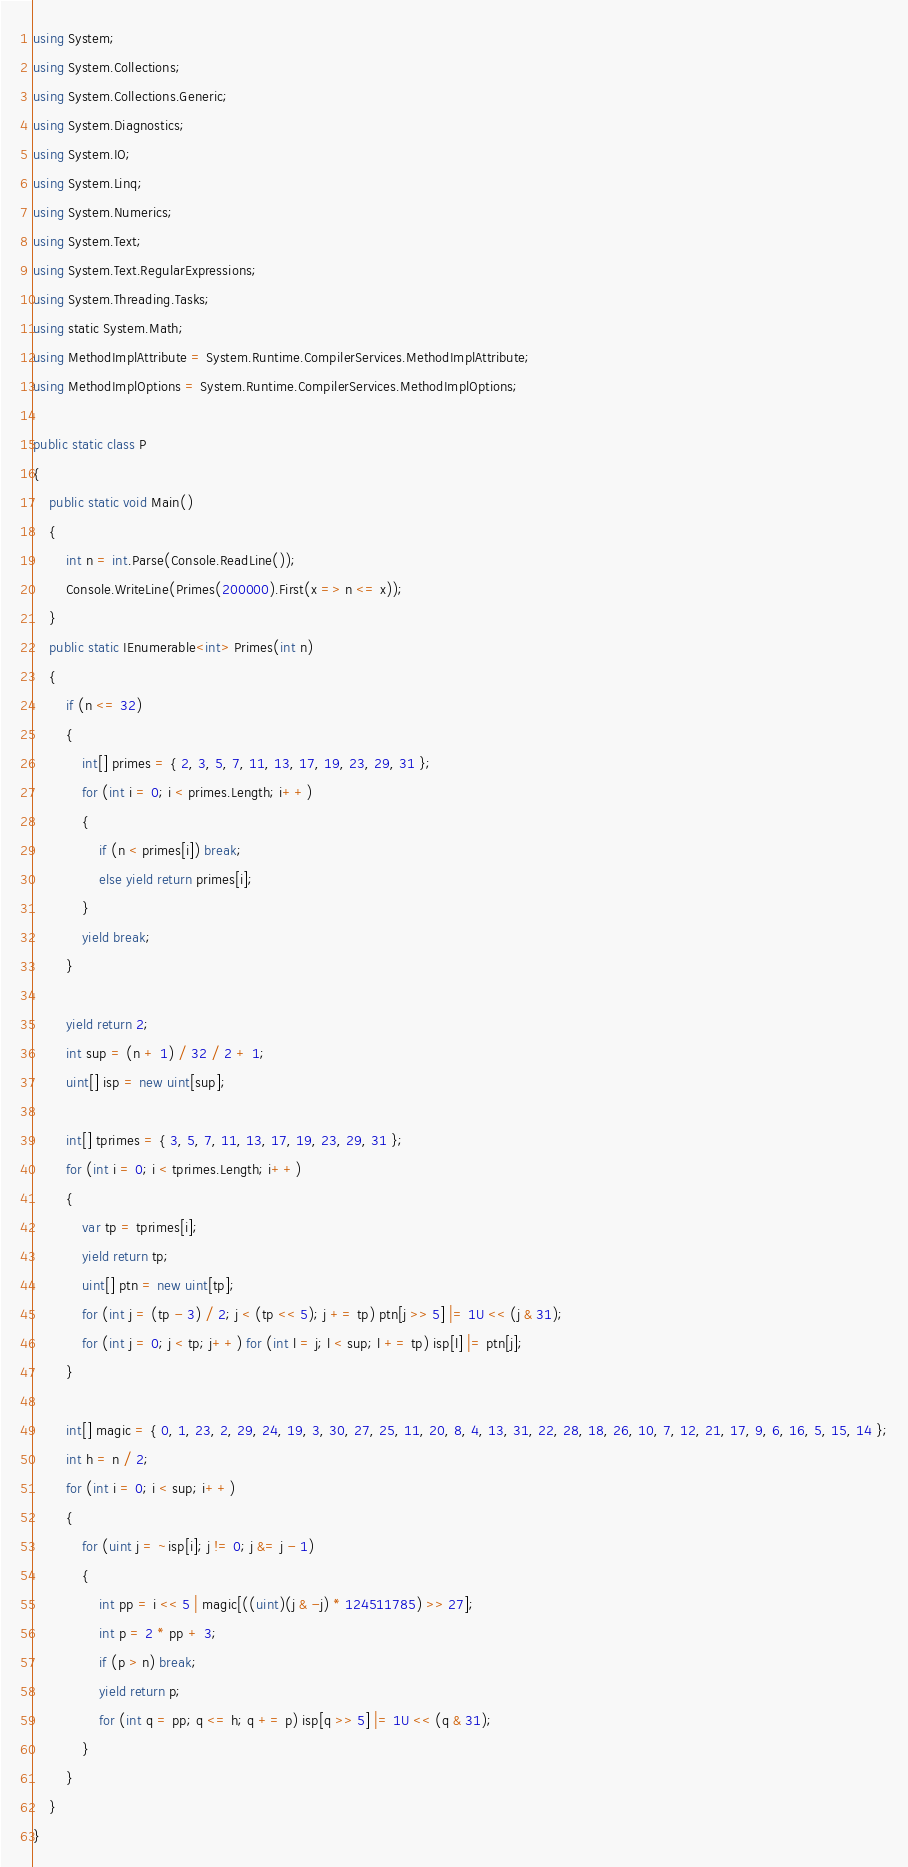Convert code to text. <code><loc_0><loc_0><loc_500><loc_500><_C#_>using System;
using System.Collections;
using System.Collections.Generic;
using System.Diagnostics;
using System.IO;
using System.Linq;
using System.Numerics;
using System.Text;
using System.Text.RegularExpressions;
using System.Threading.Tasks;
using static System.Math;
using MethodImplAttribute = System.Runtime.CompilerServices.MethodImplAttribute;
using MethodImplOptions = System.Runtime.CompilerServices.MethodImplOptions;

public static class P
{
    public static void Main()
    {
        int n = int.Parse(Console.ReadLine());
        Console.WriteLine(Primes(200000).First(x => n <= x));
    }
    public static IEnumerable<int> Primes(int n)
    {
        if (n <= 32)
        {
            int[] primes = { 2, 3, 5, 7, 11, 13, 17, 19, 23, 29, 31 };
            for (int i = 0; i < primes.Length; i++)
            {
                if (n < primes[i]) break;
                else yield return primes[i];
            }
            yield break;
        }

        yield return 2;
        int sup = (n + 1) / 32 / 2 + 1;
        uint[] isp = new uint[sup];

        int[] tprimes = { 3, 5, 7, 11, 13, 17, 19, 23, 29, 31 };
        for (int i = 0; i < tprimes.Length; i++)
        {
            var tp = tprimes[i];
            yield return tp;
            uint[] ptn = new uint[tp];
            for (int j = (tp - 3) / 2; j < (tp << 5); j += tp) ptn[j >> 5] |= 1U << (j & 31);
            for (int j = 0; j < tp; j++) for (int l = j; l < sup; l += tp) isp[l] |= ptn[j];
        }

        int[] magic = { 0, 1, 23, 2, 29, 24, 19, 3, 30, 27, 25, 11, 20, 8, 4, 13, 31, 22, 28, 18, 26, 10, 7, 12, 21, 17, 9, 6, 16, 5, 15, 14 };
        int h = n / 2;
        for (int i = 0; i < sup; i++)
        {
            for (uint j = ~isp[i]; j != 0; j &= j - 1)
            {
                int pp = i << 5 | magic[((uint)(j & -j) * 124511785) >> 27];
                int p = 2 * pp + 3;
                if (p > n) break;
                yield return p;
                for (int q = pp; q <= h; q += p) isp[q >> 5] |= 1U << (q & 31);
            }
        }
    }
}
</code> 